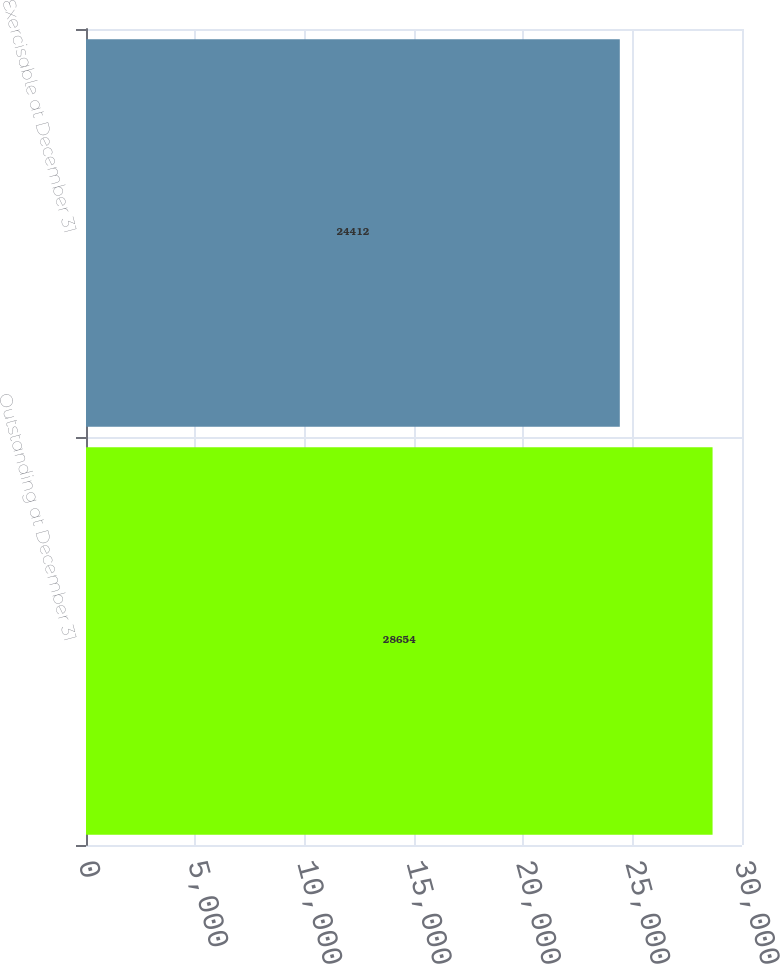<chart> <loc_0><loc_0><loc_500><loc_500><bar_chart><fcel>Outstanding at December 31<fcel>Exercisable at December 31<nl><fcel>28654<fcel>24412<nl></chart> 